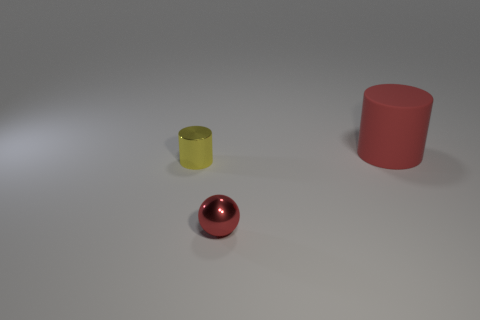Considering their sizes, how could these objects be used in real life? The objects could have various practical uses. For instance, the red and yellow cylinders might serve as containers or parts of a children's building block set. The red sphere could be a decorative item, a paperweight, or part of a larger structure, depending on its actual size and weight. 